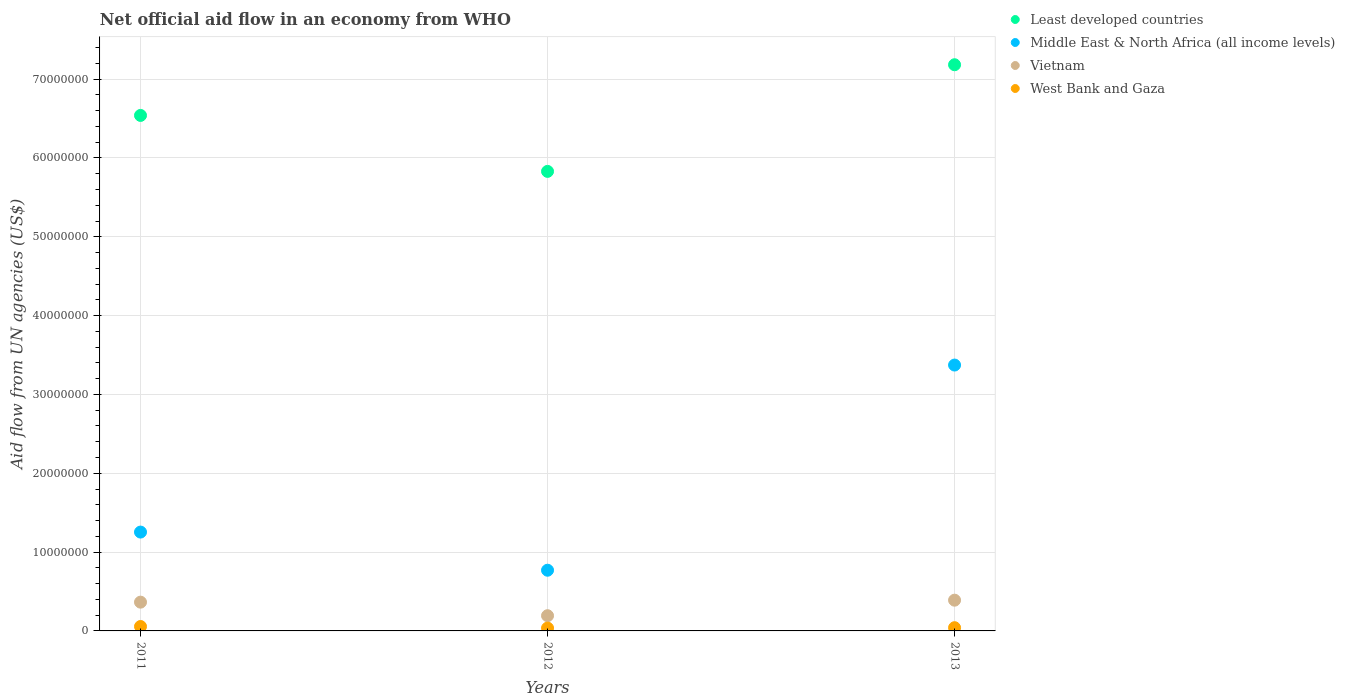What is the net official aid flow in Middle East & North Africa (all income levels) in 2013?
Offer a very short reply. 3.37e+07. Across all years, what is the maximum net official aid flow in Middle East & North Africa (all income levels)?
Ensure brevity in your answer.  3.37e+07. Across all years, what is the minimum net official aid flow in West Bank and Gaza?
Give a very brief answer. 3.60e+05. In which year was the net official aid flow in Least developed countries maximum?
Give a very brief answer. 2013. What is the total net official aid flow in West Bank and Gaza in the graph?
Your answer should be compact. 1.33e+06. What is the difference between the net official aid flow in Vietnam in 2012 and that in 2013?
Give a very brief answer. -1.97e+06. What is the difference between the net official aid flow in West Bank and Gaza in 2011 and the net official aid flow in Vietnam in 2013?
Offer a very short reply. -3.34e+06. What is the average net official aid flow in Least developed countries per year?
Your response must be concise. 6.52e+07. In the year 2012, what is the difference between the net official aid flow in Vietnam and net official aid flow in Least developed countries?
Offer a terse response. -5.64e+07. In how many years, is the net official aid flow in Vietnam greater than 2000000 US$?
Your answer should be compact. 2. What is the ratio of the net official aid flow in Least developed countries in 2012 to that in 2013?
Your answer should be very brief. 0.81. Is the net official aid flow in Middle East & North Africa (all income levels) in 2011 less than that in 2012?
Ensure brevity in your answer.  No. What is the difference between the highest and the second highest net official aid flow in Vietnam?
Your answer should be very brief. 2.50e+05. What is the difference between the highest and the lowest net official aid flow in Middle East & North Africa (all income levels)?
Keep it short and to the point. 2.60e+07. Is it the case that in every year, the sum of the net official aid flow in Vietnam and net official aid flow in Middle East & North Africa (all income levels)  is greater than the net official aid flow in West Bank and Gaza?
Give a very brief answer. Yes. Does the net official aid flow in Least developed countries monotonically increase over the years?
Offer a very short reply. No. Is the net official aid flow in Middle East & North Africa (all income levels) strictly greater than the net official aid flow in Least developed countries over the years?
Give a very brief answer. No. Is the net official aid flow in Vietnam strictly less than the net official aid flow in Least developed countries over the years?
Your answer should be compact. Yes. What is the difference between two consecutive major ticks on the Y-axis?
Offer a very short reply. 1.00e+07. Does the graph contain any zero values?
Make the answer very short. No. Does the graph contain grids?
Offer a very short reply. Yes. How many legend labels are there?
Provide a succinct answer. 4. What is the title of the graph?
Ensure brevity in your answer.  Net official aid flow in an economy from WHO. Does "United Kingdom" appear as one of the legend labels in the graph?
Ensure brevity in your answer.  No. What is the label or title of the X-axis?
Keep it short and to the point. Years. What is the label or title of the Y-axis?
Your answer should be compact. Aid flow from UN agencies (US$). What is the Aid flow from UN agencies (US$) in Least developed countries in 2011?
Offer a very short reply. 6.54e+07. What is the Aid flow from UN agencies (US$) in Middle East & North Africa (all income levels) in 2011?
Give a very brief answer. 1.25e+07. What is the Aid flow from UN agencies (US$) of Vietnam in 2011?
Your answer should be very brief. 3.65e+06. What is the Aid flow from UN agencies (US$) of West Bank and Gaza in 2011?
Make the answer very short. 5.60e+05. What is the Aid flow from UN agencies (US$) in Least developed countries in 2012?
Provide a short and direct response. 5.83e+07. What is the Aid flow from UN agencies (US$) of Middle East & North Africa (all income levels) in 2012?
Provide a succinct answer. 7.70e+06. What is the Aid flow from UN agencies (US$) in Vietnam in 2012?
Offer a very short reply. 1.93e+06. What is the Aid flow from UN agencies (US$) of West Bank and Gaza in 2012?
Make the answer very short. 3.60e+05. What is the Aid flow from UN agencies (US$) in Least developed countries in 2013?
Your response must be concise. 7.18e+07. What is the Aid flow from UN agencies (US$) in Middle East & North Africa (all income levels) in 2013?
Make the answer very short. 3.37e+07. What is the Aid flow from UN agencies (US$) in Vietnam in 2013?
Offer a terse response. 3.90e+06. What is the Aid flow from UN agencies (US$) of West Bank and Gaza in 2013?
Provide a succinct answer. 4.10e+05. Across all years, what is the maximum Aid flow from UN agencies (US$) in Least developed countries?
Provide a short and direct response. 7.18e+07. Across all years, what is the maximum Aid flow from UN agencies (US$) of Middle East & North Africa (all income levels)?
Give a very brief answer. 3.37e+07. Across all years, what is the maximum Aid flow from UN agencies (US$) in Vietnam?
Your answer should be very brief. 3.90e+06. Across all years, what is the maximum Aid flow from UN agencies (US$) in West Bank and Gaza?
Your answer should be compact. 5.60e+05. Across all years, what is the minimum Aid flow from UN agencies (US$) in Least developed countries?
Provide a short and direct response. 5.83e+07. Across all years, what is the minimum Aid flow from UN agencies (US$) in Middle East & North Africa (all income levels)?
Give a very brief answer. 7.70e+06. Across all years, what is the minimum Aid flow from UN agencies (US$) of Vietnam?
Your response must be concise. 1.93e+06. Across all years, what is the minimum Aid flow from UN agencies (US$) in West Bank and Gaza?
Offer a terse response. 3.60e+05. What is the total Aid flow from UN agencies (US$) in Least developed countries in the graph?
Provide a short and direct response. 1.96e+08. What is the total Aid flow from UN agencies (US$) in Middle East & North Africa (all income levels) in the graph?
Your response must be concise. 5.40e+07. What is the total Aid flow from UN agencies (US$) of Vietnam in the graph?
Give a very brief answer. 9.48e+06. What is the total Aid flow from UN agencies (US$) in West Bank and Gaza in the graph?
Your answer should be very brief. 1.33e+06. What is the difference between the Aid flow from UN agencies (US$) in Least developed countries in 2011 and that in 2012?
Your answer should be very brief. 7.10e+06. What is the difference between the Aid flow from UN agencies (US$) in Middle East & North Africa (all income levels) in 2011 and that in 2012?
Make the answer very short. 4.84e+06. What is the difference between the Aid flow from UN agencies (US$) of Vietnam in 2011 and that in 2012?
Offer a very short reply. 1.72e+06. What is the difference between the Aid flow from UN agencies (US$) of Least developed countries in 2011 and that in 2013?
Your response must be concise. -6.43e+06. What is the difference between the Aid flow from UN agencies (US$) of Middle East & North Africa (all income levels) in 2011 and that in 2013?
Offer a terse response. -2.12e+07. What is the difference between the Aid flow from UN agencies (US$) of Vietnam in 2011 and that in 2013?
Offer a terse response. -2.50e+05. What is the difference between the Aid flow from UN agencies (US$) of West Bank and Gaza in 2011 and that in 2013?
Make the answer very short. 1.50e+05. What is the difference between the Aid flow from UN agencies (US$) in Least developed countries in 2012 and that in 2013?
Make the answer very short. -1.35e+07. What is the difference between the Aid flow from UN agencies (US$) in Middle East & North Africa (all income levels) in 2012 and that in 2013?
Give a very brief answer. -2.60e+07. What is the difference between the Aid flow from UN agencies (US$) of Vietnam in 2012 and that in 2013?
Ensure brevity in your answer.  -1.97e+06. What is the difference between the Aid flow from UN agencies (US$) of Least developed countries in 2011 and the Aid flow from UN agencies (US$) of Middle East & North Africa (all income levels) in 2012?
Keep it short and to the point. 5.77e+07. What is the difference between the Aid flow from UN agencies (US$) of Least developed countries in 2011 and the Aid flow from UN agencies (US$) of Vietnam in 2012?
Your answer should be compact. 6.35e+07. What is the difference between the Aid flow from UN agencies (US$) of Least developed countries in 2011 and the Aid flow from UN agencies (US$) of West Bank and Gaza in 2012?
Offer a terse response. 6.50e+07. What is the difference between the Aid flow from UN agencies (US$) in Middle East & North Africa (all income levels) in 2011 and the Aid flow from UN agencies (US$) in Vietnam in 2012?
Keep it short and to the point. 1.06e+07. What is the difference between the Aid flow from UN agencies (US$) of Middle East & North Africa (all income levels) in 2011 and the Aid flow from UN agencies (US$) of West Bank and Gaza in 2012?
Offer a terse response. 1.22e+07. What is the difference between the Aid flow from UN agencies (US$) of Vietnam in 2011 and the Aid flow from UN agencies (US$) of West Bank and Gaza in 2012?
Keep it short and to the point. 3.29e+06. What is the difference between the Aid flow from UN agencies (US$) in Least developed countries in 2011 and the Aid flow from UN agencies (US$) in Middle East & North Africa (all income levels) in 2013?
Offer a very short reply. 3.17e+07. What is the difference between the Aid flow from UN agencies (US$) of Least developed countries in 2011 and the Aid flow from UN agencies (US$) of Vietnam in 2013?
Offer a very short reply. 6.15e+07. What is the difference between the Aid flow from UN agencies (US$) in Least developed countries in 2011 and the Aid flow from UN agencies (US$) in West Bank and Gaza in 2013?
Provide a succinct answer. 6.50e+07. What is the difference between the Aid flow from UN agencies (US$) of Middle East & North Africa (all income levels) in 2011 and the Aid flow from UN agencies (US$) of Vietnam in 2013?
Your response must be concise. 8.64e+06. What is the difference between the Aid flow from UN agencies (US$) of Middle East & North Africa (all income levels) in 2011 and the Aid flow from UN agencies (US$) of West Bank and Gaza in 2013?
Give a very brief answer. 1.21e+07. What is the difference between the Aid flow from UN agencies (US$) of Vietnam in 2011 and the Aid flow from UN agencies (US$) of West Bank and Gaza in 2013?
Make the answer very short. 3.24e+06. What is the difference between the Aid flow from UN agencies (US$) of Least developed countries in 2012 and the Aid flow from UN agencies (US$) of Middle East & North Africa (all income levels) in 2013?
Provide a succinct answer. 2.46e+07. What is the difference between the Aid flow from UN agencies (US$) of Least developed countries in 2012 and the Aid flow from UN agencies (US$) of Vietnam in 2013?
Your answer should be compact. 5.44e+07. What is the difference between the Aid flow from UN agencies (US$) in Least developed countries in 2012 and the Aid flow from UN agencies (US$) in West Bank and Gaza in 2013?
Your answer should be compact. 5.79e+07. What is the difference between the Aid flow from UN agencies (US$) in Middle East & North Africa (all income levels) in 2012 and the Aid flow from UN agencies (US$) in Vietnam in 2013?
Provide a succinct answer. 3.80e+06. What is the difference between the Aid flow from UN agencies (US$) of Middle East & North Africa (all income levels) in 2012 and the Aid flow from UN agencies (US$) of West Bank and Gaza in 2013?
Offer a very short reply. 7.29e+06. What is the difference between the Aid flow from UN agencies (US$) of Vietnam in 2012 and the Aid flow from UN agencies (US$) of West Bank and Gaza in 2013?
Keep it short and to the point. 1.52e+06. What is the average Aid flow from UN agencies (US$) in Least developed countries per year?
Provide a succinct answer. 6.52e+07. What is the average Aid flow from UN agencies (US$) of Middle East & North Africa (all income levels) per year?
Keep it short and to the point. 1.80e+07. What is the average Aid flow from UN agencies (US$) of Vietnam per year?
Provide a succinct answer. 3.16e+06. What is the average Aid flow from UN agencies (US$) in West Bank and Gaza per year?
Ensure brevity in your answer.  4.43e+05. In the year 2011, what is the difference between the Aid flow from UN agencies (US$) in Least developed countries and Aid flow from UN agencies (US$) in Middle East & North Africa (all income levels)?
Your answer should be very brief. 5.29e+07. In the year 2011, what is the difference between the Aid flow from UN agencies (US$) of Least developed countries and Aid flow from UN agencies (US$) of Vietnam?
Provide a short and direct response. 6.18e+07. In the year 2011, what is the difference between the Aid flow from UN agencies (US$) in Least developed countries and Aid flow from UN agencies (US$) in West Bank and Gaza?
Your response must be concise. 6.48e+07. In the year 2011, what is the difference between the Aid flow from UN agencies (US$) in Middle East & North Africa (all income levels) and Aid flow from UN agencies (US$) in Vietnam?
Your response must be concise. 8.89e+06. In the year 2011, what is the difference between the Aid flow from UN agencies (US$) in Middle East & North Africa (all income levels) and Aid flow from UN agencies (US$) in West Bank and Gaza?
Provide a succinct answer. 1.20e+07. In the year 2011, what is the difference between the Aid flow from UN agencies (US$) in Vietnam and Aid flow from UN agencies (US$) in West Bank and Gaza?
Offer a very short reply. 3.09e+06. In the year 2012, what is the difference between the Aid flow from UN agencies (US$) in Least developed countries and Aid flow from UN agencies (US$) in Middle East & North Africa (all income levels)?
Your response must be concise. 5.06e+07. In the year 2012, what is the difference between the Aid flow from UN agencies (US$) in Least developed countries and Aid flow from UN agencies (US$) in Vietnam?
Provide a short and direct response. 5.64e+07. In the year 2012, what is the difference between the Aid flow from UN agencies (US$) in Least developed countries and Aid flow from UN agencies (US$) in West Bank and Gaza?
Give a very brief answer. 5.79e+07. In the year 2012, what is the difference between the Aid flow from UN agencies (US$) of Middle East & North Africa (all income levels) and Aid flow from UN agencies (US$) of Vietnam?
Give a very brief answer. 5.77e+06. In the year 2012, what is the difference between the Aid flow from UN agencies (US$) of Middle East & North Africa (all income levels) and Aid flow from UN agencies (US$) of West Bank and Gaza?
Your response must be concise. 7.34e+06. In the year 2012, what is the difference between the Aid flow from UN agencies (US$) of Vietnam and Aid flow from UN agencies (US$) of West Bank and Gaza?
Your answer should be very brief. 1.57e+06. In the year 2013, what is the difference between the Aid flow from UN agencies (US$) in Least developed countries and Aid flow from UN agencies (US$) in Middle East & North Africa (all income levels)?
Provide a short and direct response. 3.81e+07. In the year 2013, what is the difference between the Aid flow from UN agencies (US$) of Least developed countries and Aid flow from UN agencies (US$) of Vietnam?
Your answer should be compact. 6.79e+07. In the year 2013, what is the difference between the Aid flow from UN agencies (US$) of Least developed countries and Aid flow from UN agencies (US$) of West Bank and Gaza?
Your answer should be compact. 7.14e+07. In the year 2013, what is the difference between the Aid flow from UN agencies (US$) of Middle East & North Africa (all income levels) and Aid flow from UN agencies (US$) of Vietnam?
Your answer should be compact. 2.98e+07. In the year 2013, what is the difference between the Aid flow from UN agencies (US$) in Middle East & North Africa (all income levels) and Aid flow from UN agencies (US$) in West Bank and Gaza?
Offer a terse response. 3.33e+07. In the year 2013, what is the difference between the Aid flow from UN agencies (US$) of Vietnam and Aid flow from UN agencies (US$) of West Bank and Gaza?
Provide a succinct answer. 3.49e+06. What is the ratio of the Aid flow from UN agencies (US$) of Least developed countries in 2011 to that in 2012?
Offer a very short reply. 1.12. What is the ratio of the Aid flow from UN agencies (US$) of Middle East & North Africa (all income levels) in 2011 to that in 2012?
Offer a terse response. 1.63. What is the ratio of the Aid flow from UN agencies (US$) in Vietnam in 2011 to that in 2012?
Offer a terse response. 1.89. What is the ratio of the Aid flow from UN agencies (US$) of West Bank and Gaza in 2011 to that in 2012?
Make the answer very short. 1.56. What is the ratio of the Aid flow from UN agencies (US$) of Least developed countries in 2011 to that in 2013?
Provide a short and direct response. 0.91. What is the ratio of the Aid flow from UN agencies (US$) in Middle East & North Africa (all income levels) in 2011 to that in 2013?
Make the answer very short. 0.37. What is the ratio of the Aid flow from UN agencies (US$) in Vietnam in 2011 to that in 2013?
Offer a terse response. 0.94. What is the ratio of the Aid flow from UN agencies (US$) in West Bank and Gaza in 2011 to that in 2013?
Give a very brief answer. 1.37. What is the ratio of the Aid flow from UN agencies (US$) of Least developed countries in 2012 to that in 2013?
Offer a terse response. 0.81. What is the ratio of the Aid flow from UN agencies (US$) of Middle East & North Africa (all income levels) in 2012 to that in 2013?
Offer a very short reply. 0.23. What is the ratio of the Aid flow from UN agencies (US$) in Vietnam in 2012 to that in 2013?
Provide a succinct answer. 0.49. What is the ratio of the Aid flow from UN agencies (US$) in West Bank and Gaza in 2012 to that in 2013?
Offer a terse response. 0.88. What is the difference between the highest and the second highest Aid flow from UN agencies (US$) in Least developed countries?
Ensure brevity in your answer.  6.43e+06. What is the difference between the highest and the second highest Aid flow from UN agencies (US$) in Middle East & North Africa (all income levels)?
Offer a terse response. 2.12e+07. What is the difference between the highest and the second highest Aid flow from UN agencies (US$) in Vietnam?
Your response must be concise. 2.50e+05. What is the difference between the highest and the second highest Aid flow from UN agencies (US$) of West Bank and Gaza?
Ensure brevity in your answer.  1.50e+05. What is the difference between the highest and the lowest Aid flow from UN agencies (US$) of Least developed countries?
Your response must be concise. 1.35e+07. What is the difference between the highest and the lowest Aid flow from UN agencies (US$) in Middle East & North Africa (all income levels)?
Your answer should be compact. 2.60e+07. What is the difference between the highest and the lowest Aid flow from UN agencies (US$) of Vietnam?
Offer a terse response. 1.97e+06. What is the difference between the highest and the lowest Aid flow from UN agencies (US$) in West Bank and Gaza?
Give a very brief answer. 2.00e+05. 